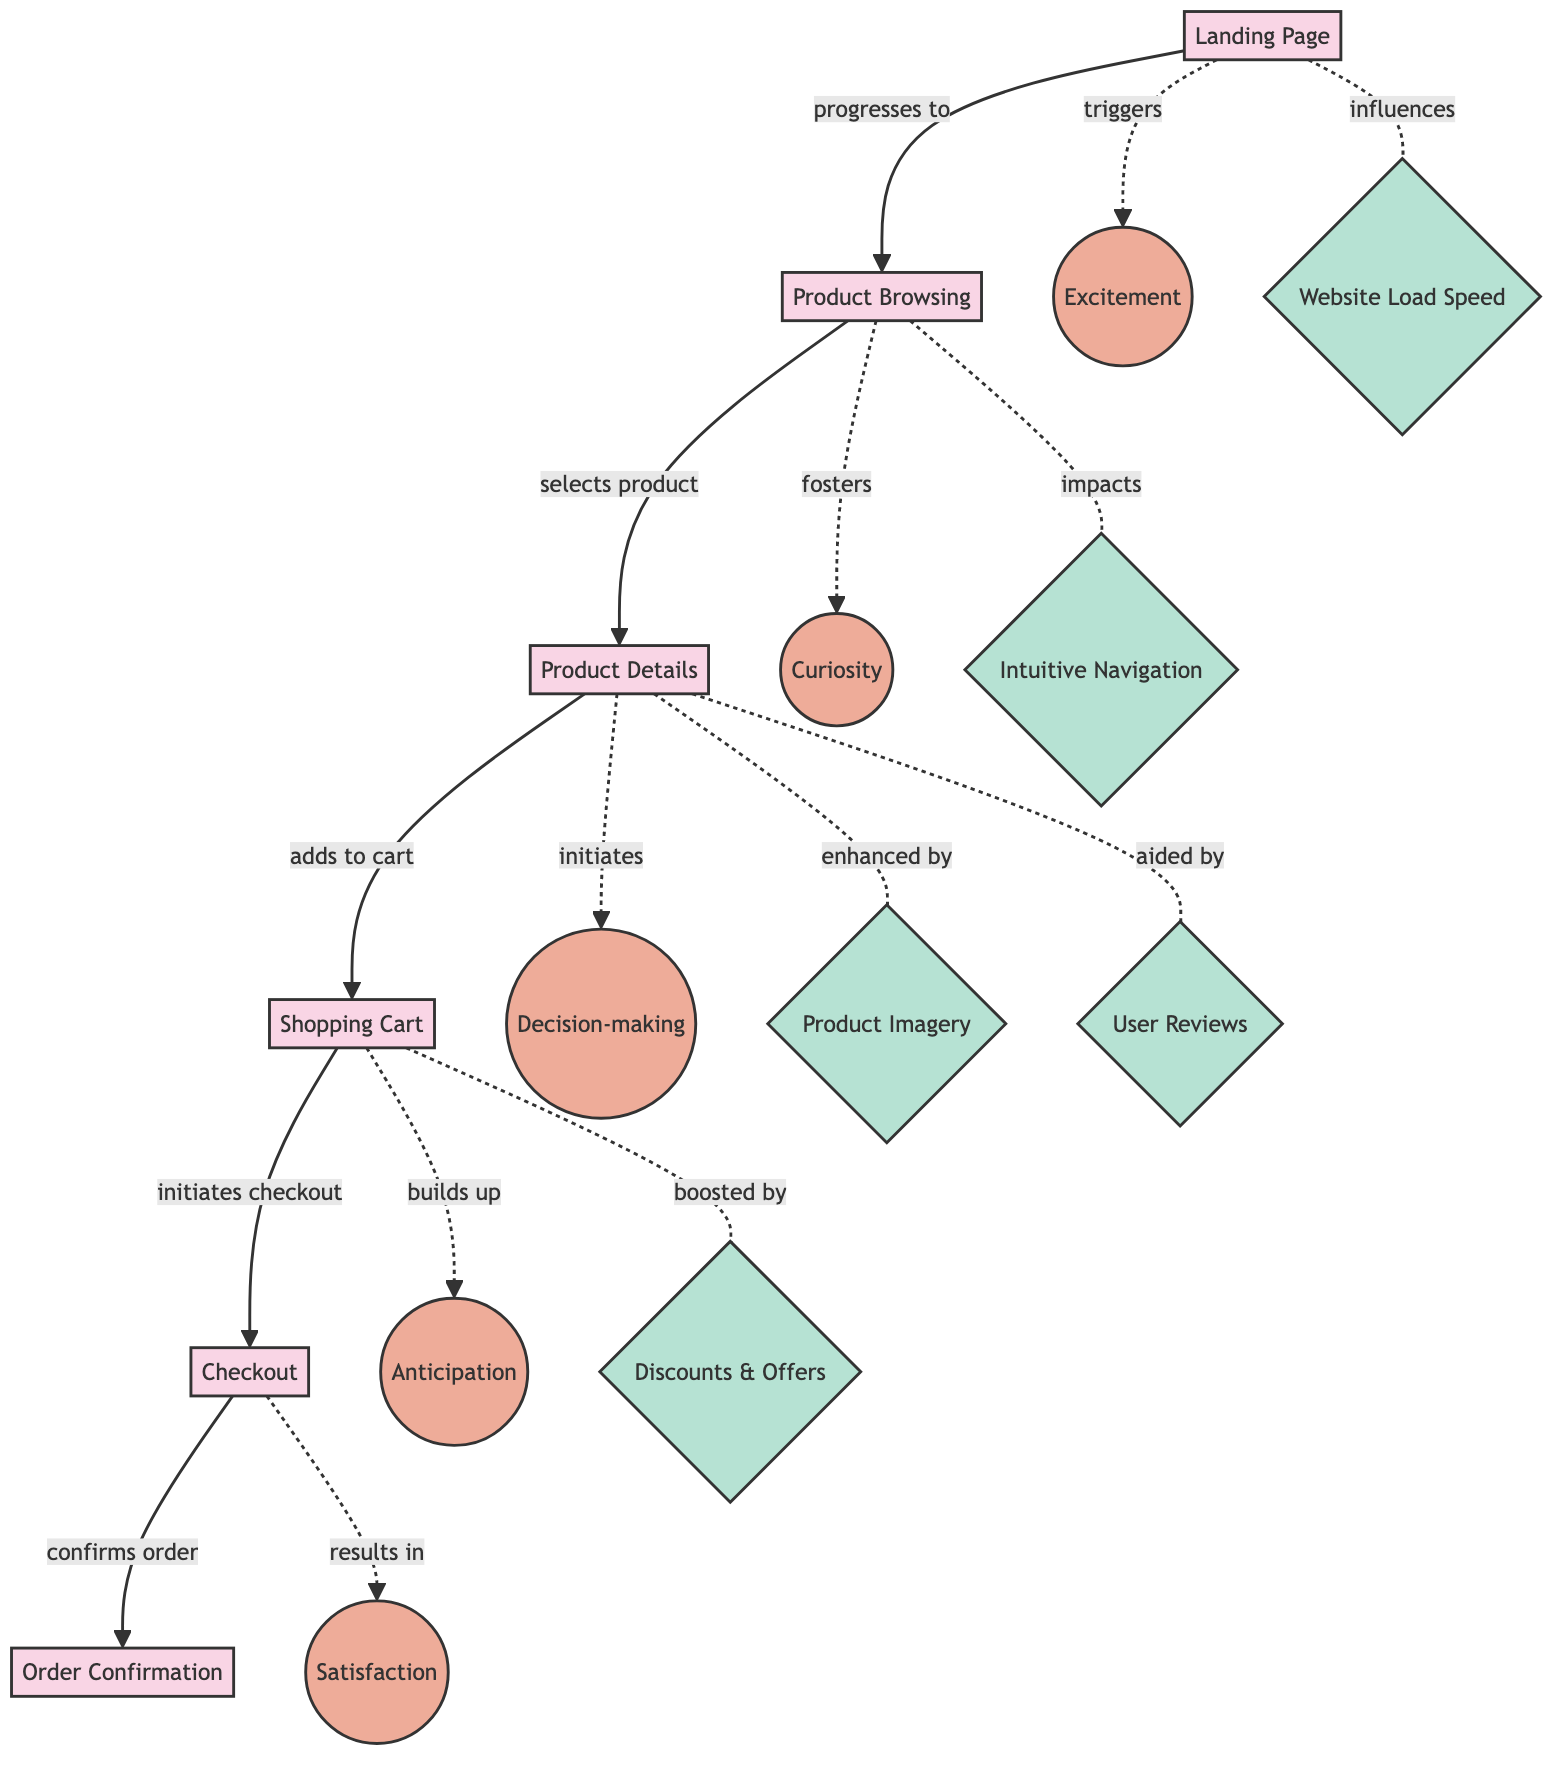What is the first stage in the user journey? The first node in the diagram, labeled "Landing Page," represents the initial stage users encounter when visiting the website, which is indicated as the starting point.
Answer: Landing Page How many emotional states are shown in the diagram? By counting the nodes categorized under "Emotional State," there are five distinct emotional states represented in the diagram.
Answer: 5 Which emotional state is triggered by the Landing Page? The link from "Landing Page" to "Excitement" is marked as "triggers," indicating that users feel excitement upon arriving at the landing page.
Answer: Excitement What part of the user journey does "Checking Out" lead to? Following the directed link labeled "confirms order," we see that "Checkout" leads to "Order Confirmation," which is the subsequent stage upon completing a checkout.
Answer: Order Confirmation What UX factor affects product browsing? The line indicating that "Product Browsing" is influenced by "Intuitive Navigation" suggests that this aspect of UX plays a significant role in how users navigate and find products while browsing.
Answer: Intuitive Navigation Which emotional state is associated with evaluating product needs? Observing the connection where "Product Details" initiates "Decision-making," we determine that this emotional state reflects users evaluating whether the product fits their needs.
Answer: Decision-making How many stages are mentioned from Landing Page to Order Confirmation? Counting the nodes labeled as stages, which include "Landing Page," "Product Browsing," "Product Details," "Shopping Cart," "Checkout," and "Order Confirmation," we find there are six stages in total.
Answer: 6 What enhances the user experience during Product Details? The diagram shows two connections: "Product Details" is enhanced by "Product Imagery" and aided by "User Reviews," indicating that both factors contribute positively to the user experience at this stage.
Answer: Product Imagery, User Reviews What is the final emotional state after completing a purchase? The link from "Checkout" to "Satisfaction" indicates that users feel satisfaction once they have confirmed their purchase, marking the conclusion of the journey in terms of emotional response.
Answer: Satisfaction 